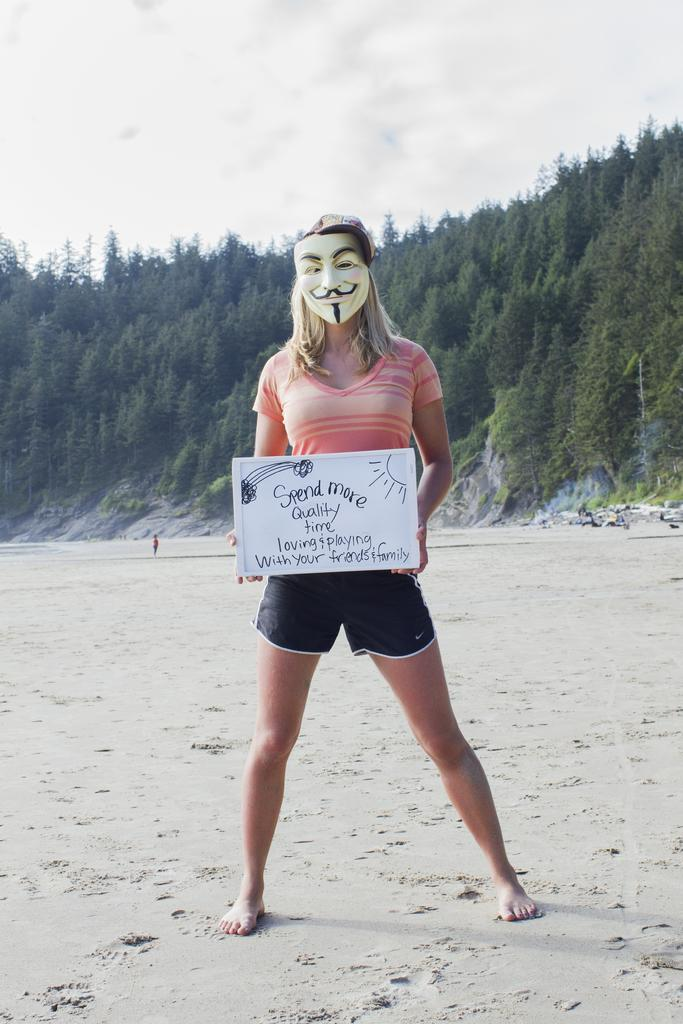Who is the main subject in the image? There is a woman in the image. What is the woman holding in the image? The woman is holding a board. What can be seen on the board? There is text and figures on the board. What is visible in the background of the image? There are trees in the background of the image. What is visible at the top of the image? The sky is visible at the top of the image. What type of book is the woman reading in the image? There is no book present in the image; the woman is holding a board with text and figures on it. 